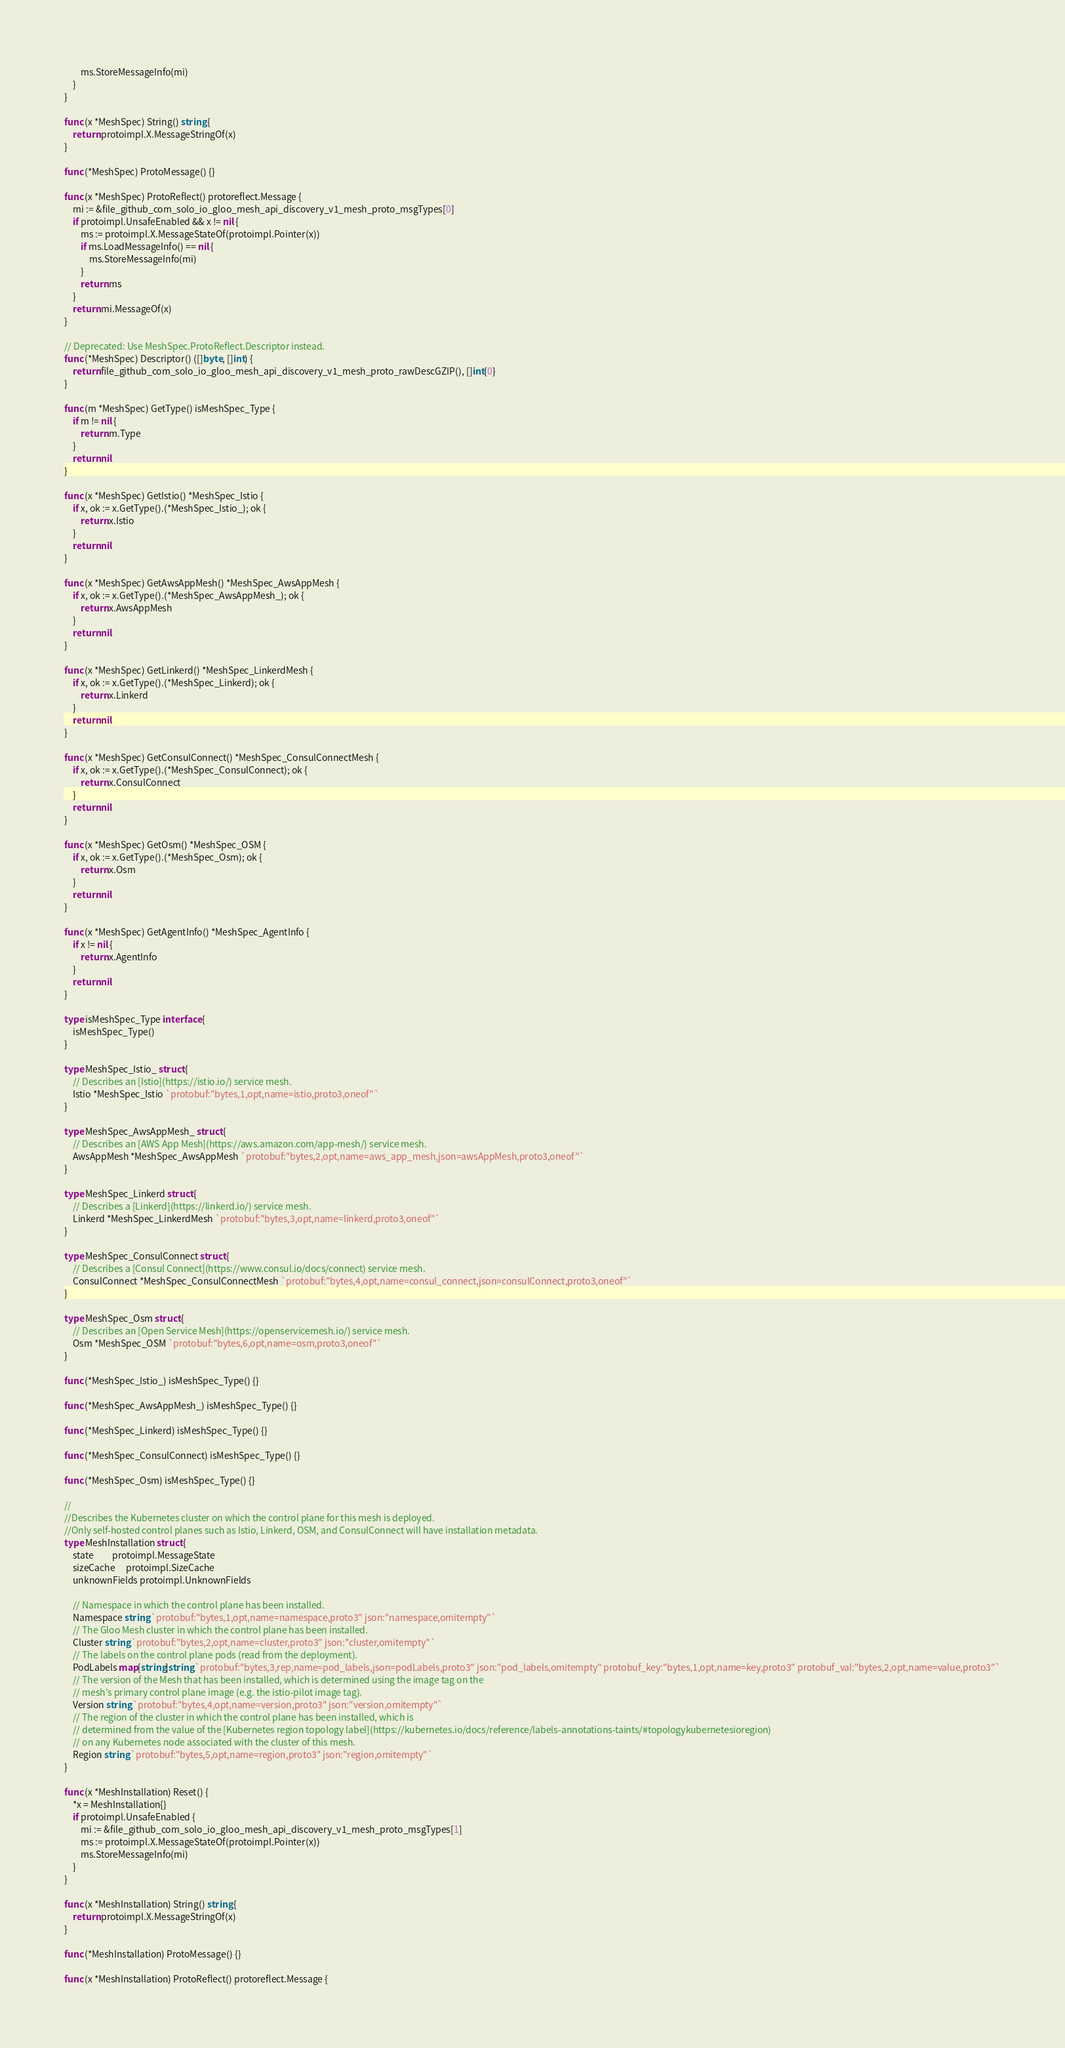Convert code to text. <code><loc_0><loc_0><loc_500><loc_500><_Go_>		ms.StoreMessageInfo(mi)
	}
}

func (x *MeshSpec) String() string {
	return protoimpl.X.MessageStringOf(x)
}

func (*MeshSpec) ProtoMessage() {}

func (x *MeshSpec) ProtoReflect() protoreflect.Message {
	mi := &file_github_com_solo_io_gloo_mesh_api_discovery_v1_mesh_proto_msgTypes[0]
	if protoimpl.UnsafeEnabled && x != nil {
		ms := protoimpl.X.MessageStateOf(protoimpl.Pointer(x))
		if ms.LoadMessageInfo() == nil {
			ms.StoreMessageInfo(mi)
		}
		return ms
	}
	return mi.MessageOf(x)
}

// Deprecated: Use MeshSpec.ProtoReflect.Descriptor instead.
func (*MeshSpec) Descriptor() ([]byte, []int) {
	return file_github_com_solo_io_gloo_mesh_api_discovery_v1_mesh_proto_rawDescGZIP(), []int{0}
}

func (m *MeshSpec) GetType() isMeshSpec_Type {
	if m != nil {
		return m.Type
	}
	return nil
}

func (x *MeshSpec) GetIstio() *MeshSpec_Istio {
	if x, ok := x.GetType().(*MeshSpec_Istio_); ok {
		return x.Istio
	}
	return nil
}

func (x *MeshSpec) GetAwsAppMesh() *MeshSpec_AwsAppMesh {
	if x, ok := x.GetType().(*MeshSpec_AwsAppMesh_); ok {
		return x.AwsAppMesh
	}
	return nil
}

func (x *MeshSpec) GetLinkerd() *MeshSpec_LinkerdMesh {
	if x, ok := x.GetType().(*MeshSpec_Linkerd); ok {
		return x.Linkerd
	}
	return nil
}

func (x *MeshSpec) GetConsulConnect() *MeshSpec_ConsulConnectMesh {
	if x, ok := x.GetType().(*MeshSpec_ConsulConnect); ok {
		return x.ConsulConnect
	}
	return nil
}

func (x *MeshSpec) GetOsm() *MeshSpec_OSM {
	if x, ok := x.GetType().(*MeshSpec_Osm); ok {
		return x.Osm
	}
	return nil
}

func (x *MeshSpec) GetAgentInfo() *MeshSpec_AgentInfo {
	if x != nil {
		return x.AgentInfo
	}
	return nil
}

type isMeshSpec_Type interface {
	isMeshSpec_Type()
}

type MeshSpec_Istio_ struct {
	// Describes an [Istio](https://istio.io/) service mesh.
	Istio *MeshSpec_Istio `protobuf:"bytes,1,opt,name=istio,proto3,oneof"`
}

type MeshSpec_AwsAppMesh_ struct {
	// Describes an [AWS App Mesh](https://aws.amazon.com/app-mesh/) service mesh.
	AwsAppMesh *MeshSpec_AwsAppMesh `protobuf:"bytes,2,opt,name=aws_app_mesh,json=awsAppMesh,proto3,oneof"`
}

type MeshSpec_Linkerd struct {
	// Describes a [Linkerd](https://linkerd.io/) service mesh.
	Linkerd *MeshSpec_LinkerdMesh `protobuf:"bytes,3,opt,name=linkerd,proto3,oneof"`
}

type MeshSpec_ConsulConnect struct {
	// Describes a [Consul Connect](https://www.consul.io/docs/connect) service mesh.
	ConsulConnect *MeshSpec_ConsulConnectMesh `protobuf:"bytes,4,opt,name=consul_connect,json=consulConnect,proto3,oneof"`
}

type MeshSpec_Osm struct {
	// Describes an [Open Service Mesh](https://openservicemesh.io/) service mesh.
	Osm *MeshSpec_OSM `protobuf:"bytes,6,opt,name=osm,proto3,oneof"`
}

func (*MeshSpec_Istio_) isMeshSpec_Type() {}

func (*MeshSpec_AwsAppMesh_) isMeshSpec_Type() {}

func (*MeshSpec_Linkerd) isMeshSpec_Type() {}

func (*MeshSpec_ConsulConnect) isMeshSpec_Type() {}

func (*MeshSpec_Osm) isMeshSpec_Type() {}

//
//Describes the Kubernetes cluster on which the control plane for this mesh is deployed.
//Only self-hosted control planes such as Istio, Linkerd, OSM, and ConsulConnect will have installation metadata.
type MeshInstallation struct {
	state         protoimpl.MessageState
	sizeCache     protoimpl.SizeCache
	unknownFields protoimpl.UnknownFields

	// Namespace in which the control plane has been installed.
	Namespace string `protobuf:"bytes,1,opt,name=namespace,proto3" json:"namespace,omitempty"`
	// The Gloo Mesh cluster in which the control plane has been installed.
	Cluster string `protobuf:"bytes,2,opt,name=cluster,proto3" json:"cluster,omitempty"`
	// The labels on the control plane pods (read from the deployment).
	PodLabels map[string]string `protobuf:"bytes,3,rep,name=pod_labels,json=podLabels,proto3" json:"pod_labels,omitempty" protobuf_key:"bytes,1,opt,name=key,proto3" protobuf_val:"bytes,2,opt,name=value,proto3"`
	// The version of the Mesh that has been installed, which is determined using the image tag on the
	// mesh's primary control plane image (e.g. the istio-pilot image tag).
	Version string `protobuf:"bytes,4,opt,name=version,proto3" json:"version,omitempty"`
	// The region of the cluster in which the control plane has been installed, which is
	// determined from the value of the [Kubernetes region topology label](https://kubernetes.io/docs/reference/labels-annotations-taints/#topologykubernetesioregion)
	// on any Kubernetes node associated with the cluster of this mesh.
	Region string `protobuf:"bytes,5,opt,name=region,proto3" json:"region,omitempty"`
}

func (x *MeshInstallation) Reset() {
	*x = MeshInstallation{}
	if protoimpl.UnsafeEnabled {
		mi := &file_github_com_solo_io_gloo_mesh_api_discovery_v1_mesh_proto_msgTypes[1]
		ms := protoimpl.X.MessageStateOf(protoimpl.Pointer(x))
		ms.StoreMessageInfo(mi)
	}
}

func (x *MeshInstallation) String() string {
	return protoimpl.X.MessageStringOf(x)
}

func (*MeshInstallation) ProtoMessage() {}

func (x *MeshInstallation) ProtoReflect() protoreflect.Message {</code> 